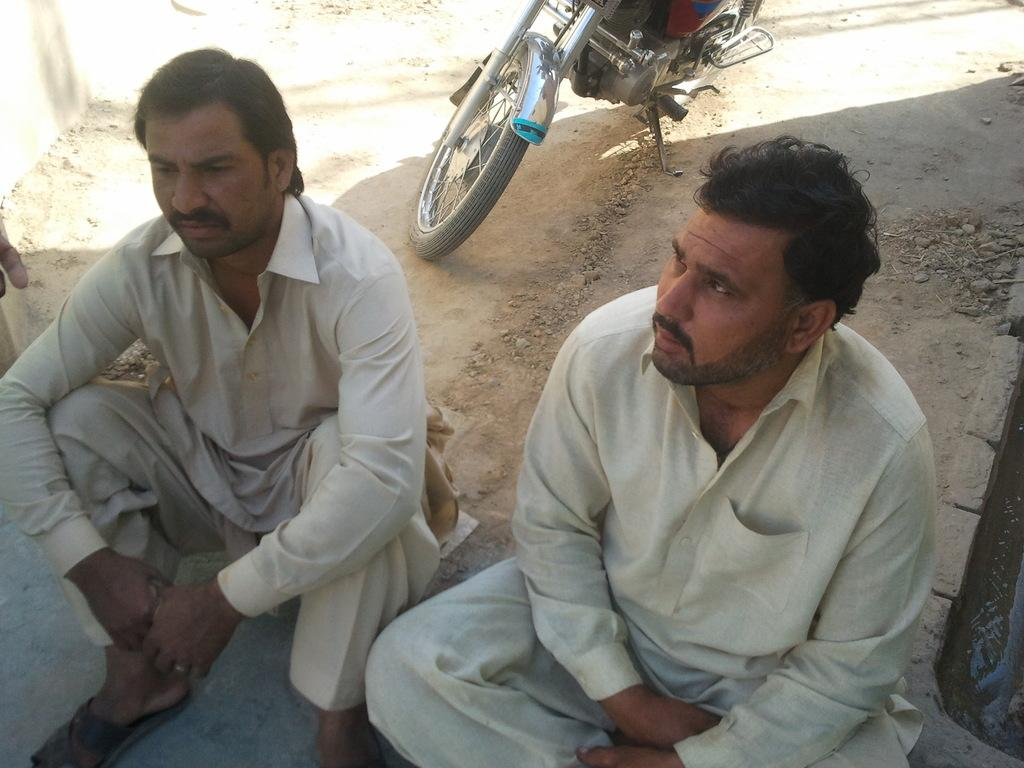How many people are in the image? There are persons in the image, but the exact number is not specified. What are the persons wearing? The persons are wearing clothes. What position are the persons in? The persons are sitting on the ground. What can be seen at the top of the image? There is a motorcycle at the top of the image. What type of locket is the person wearing around their neck in the image? There is no mention of a locket or any jewelry in the image. How far away is the edge of the image from the persons sitting on the ground? The concept of distance from the edge of the image is not applicable, as the image is a two-dimensional representation. 